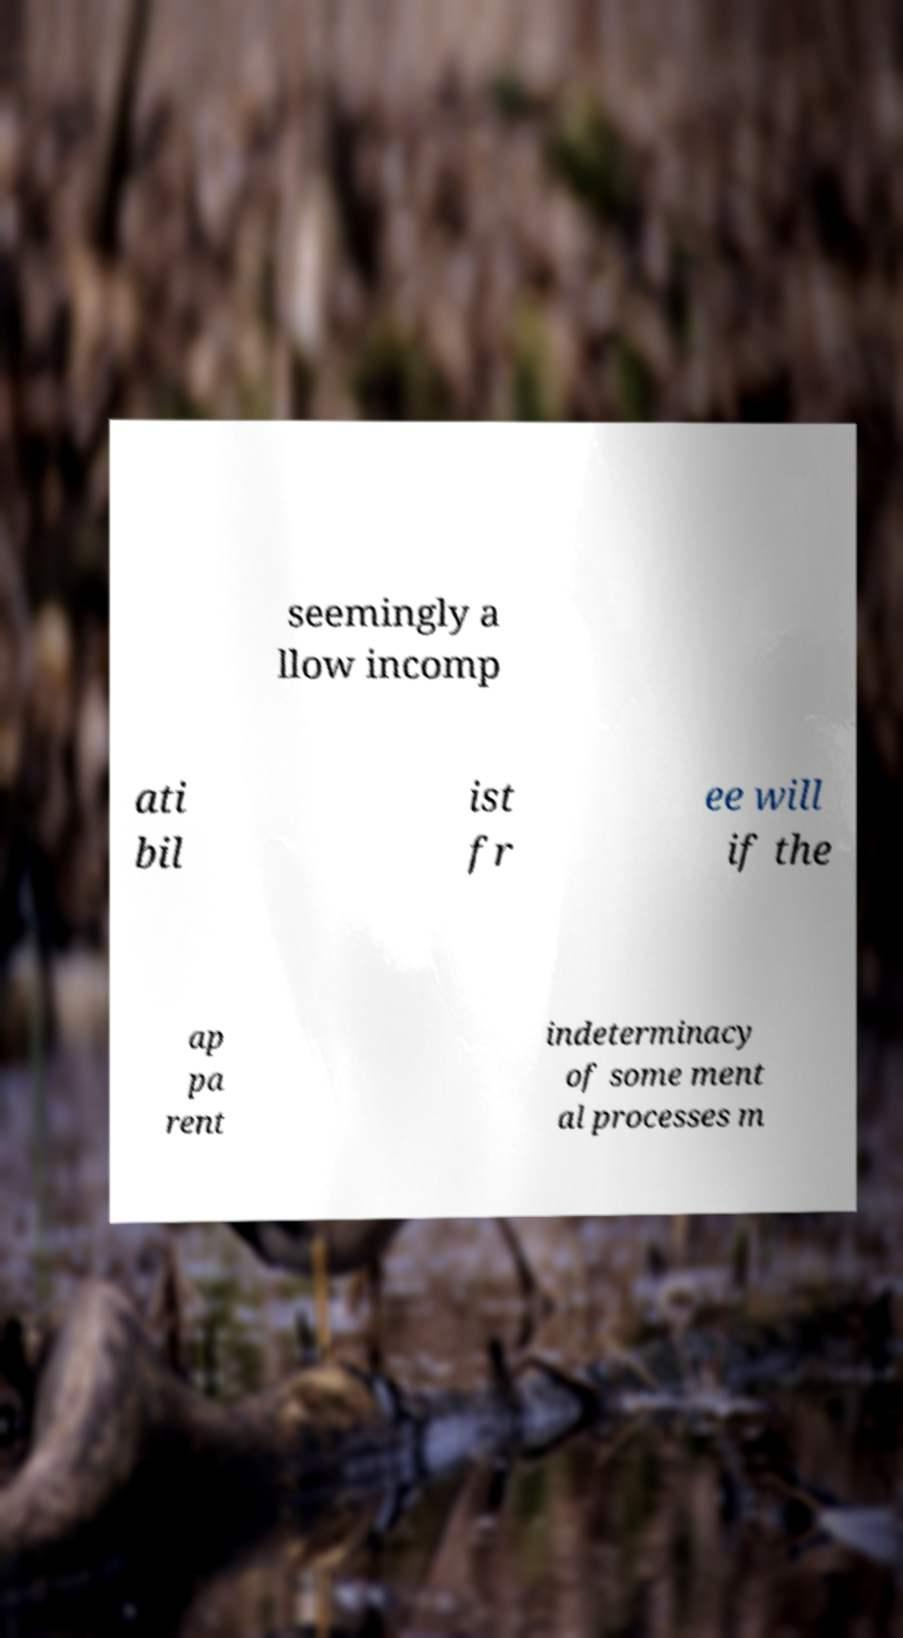Please read and relay the text visible in this image. What does it say? seemingly a llow incomp ati bil ist fr ee will if the ap pa rent indeterminacy of some ment al processes m 